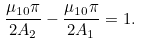Convert formula to latex. <formula><loc_0><loc_0><loc_500><loc_500>\frac { \mu _ { 1 0 } \pi } { 2 A _ { 2 } } - \frac { \mu _ { 1 0 } \pi } { 2 A _ { 1 } } = 1 .</formula> 